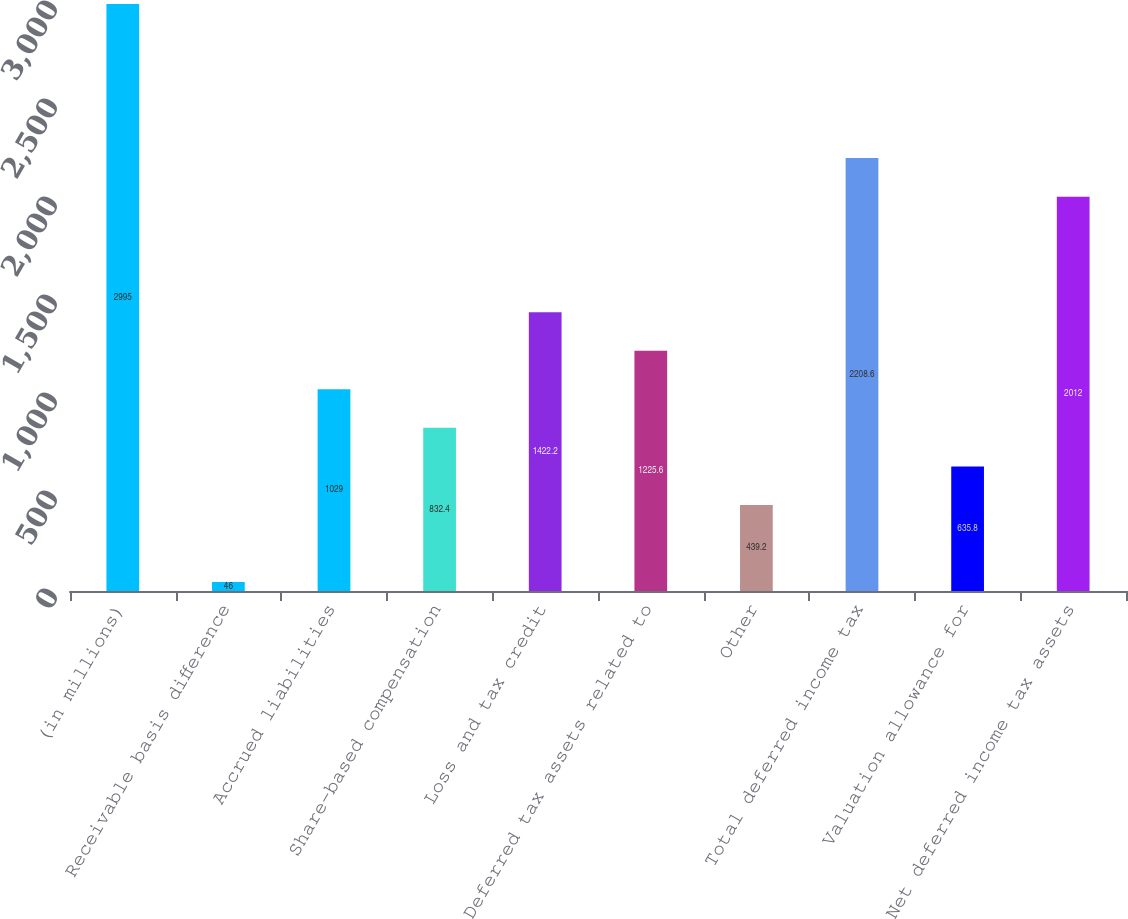<chart> <loc_0><loc_0><loc_500><loc_500><bar_chart><fcel>(in millions)<fcel>Receivable basis difference<fcel>Accrued liabilities<fcel>Share-based compensation<fcel>Loss and tax credit<fcel>Deferred tax assets related to<fcel>Other<fcel>Total deferred income tax<fcel>Valuation allowance for<fcel>Net deferred income tax assets<nl><fcel>2995<fcel>46<fcel>1029<fcel>832.4<fcel>1422.2<fcel>1225.6<fcel>439.2<fcel>2208.6<fcel>635.8<fcel>2012<nl></chart> 